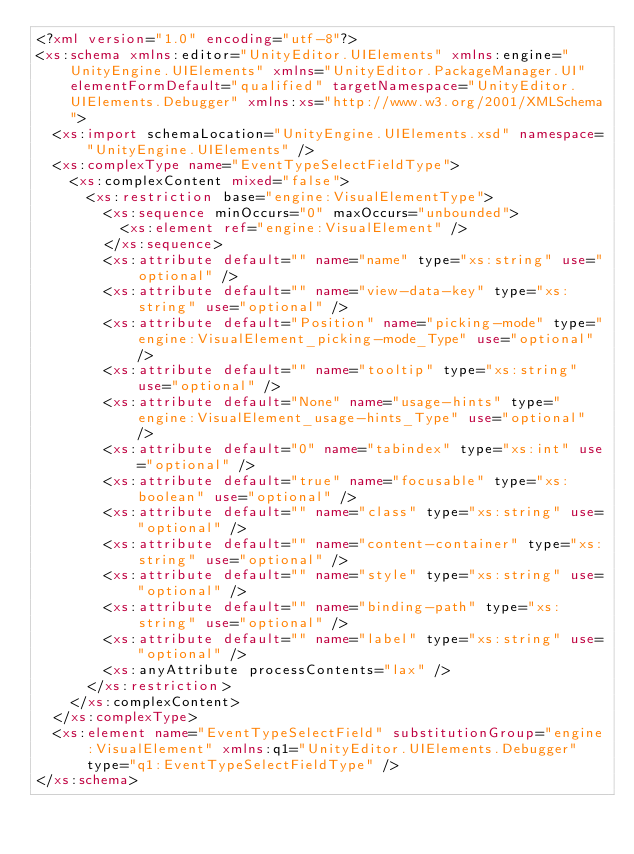<code> <loc_0><loc_0><loc_500><loc_500><_XML_><?xml version="1.0" encoding="utf-8"?>
<xs:schema xmlns:editor="UnityEditor.UIElements" xmlns:engine="UnityEngine.UIElements" xmlns="UnityEditor.PackageManager.UI" elementFormDefault="qualified" targetNamespace="UnityEditor.UIElements.Debugger" xmlns:xs="http://www.w3.org/2001/XMLSchema">
  <xs:import schemaLocation="UnityEngine.UIElements.xsd" namespace="UnityEngine.UIElements" />
  <xs:complexType name="EventTypeSelectFieldType">
    <xs:complexContent mixed="false">
      <xs:restriction base="engine:VisualElementType">
        <xs:sequence minOccurs="0" maxOccurs="unbounded">
          <xs:element ref="engine:VisualElement" />
        </xs:sequence>
        <xs:attribute default="" name="name" type="xs:string" use="optional" />
        <xs:attribute default="" name="view-data-key" type="xs:string" use="optional" />
        <xs:attribute default="Position" name="picking-mode" type="engine:VisualElement_picking-mode_Type" use="optional" />
        <xs:attribute default="" name="tooltip" type="xs:string" use="optional" />
        <xs:attribute default="None" name="usage-hints" type="engine:VisualElement_usage-hints_Type" use="optional" />
        <xs:attribute default="0" name="tabindex" type="xs:int" use="optional" />
        <xs:attribute default="true" name="focusable" type="xs:boolean" use="optional" />
        <xs:attribute default="" name="class" type="xs:string" use="optional" />
        <xs:attribute default="" name="content-container" type="xs:string" use="optional" />
        <xs:attribute default="" name="style" type="xs:string" use="optional" />
        <xs:attribute default="" name="binding-path" type="xs:string" use="optional" />
        <xs:attribute default="" name="label" type="xs:string" use="optional" />
        <xs:anyAttribute processContents="lax" />
      </xs:restriction>
    </xs:complexContent>
  </xs:complexType>
  <xs:element name="EventTypeSelectField" substitutionGroup="engine:VisualElement" xmlns:q1="UnityEditor.UIElements.Debugger" type="q1:EventTypeSelectFieldType" />
</xs:schema></code> 